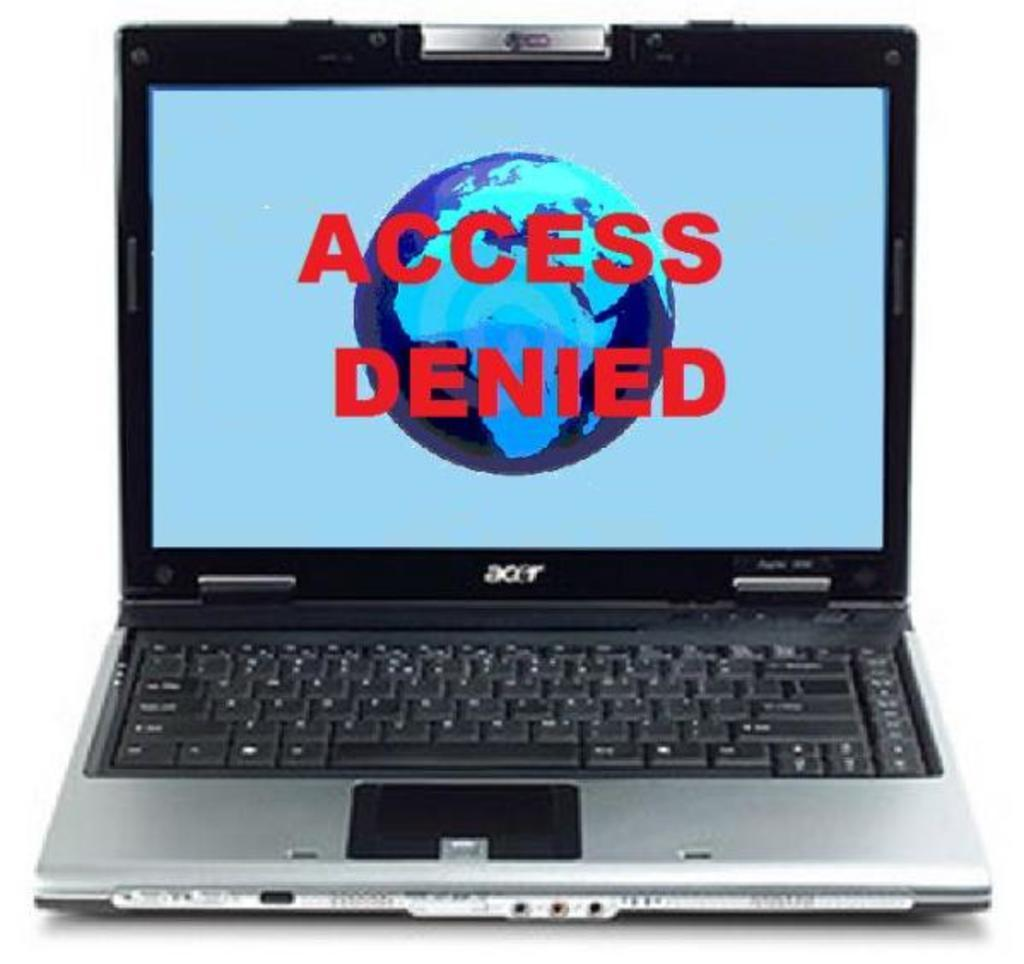<image>
Present a compact description of the photo's key features. The acer laptop displays a warning screen with access denied displayed in large red font. 